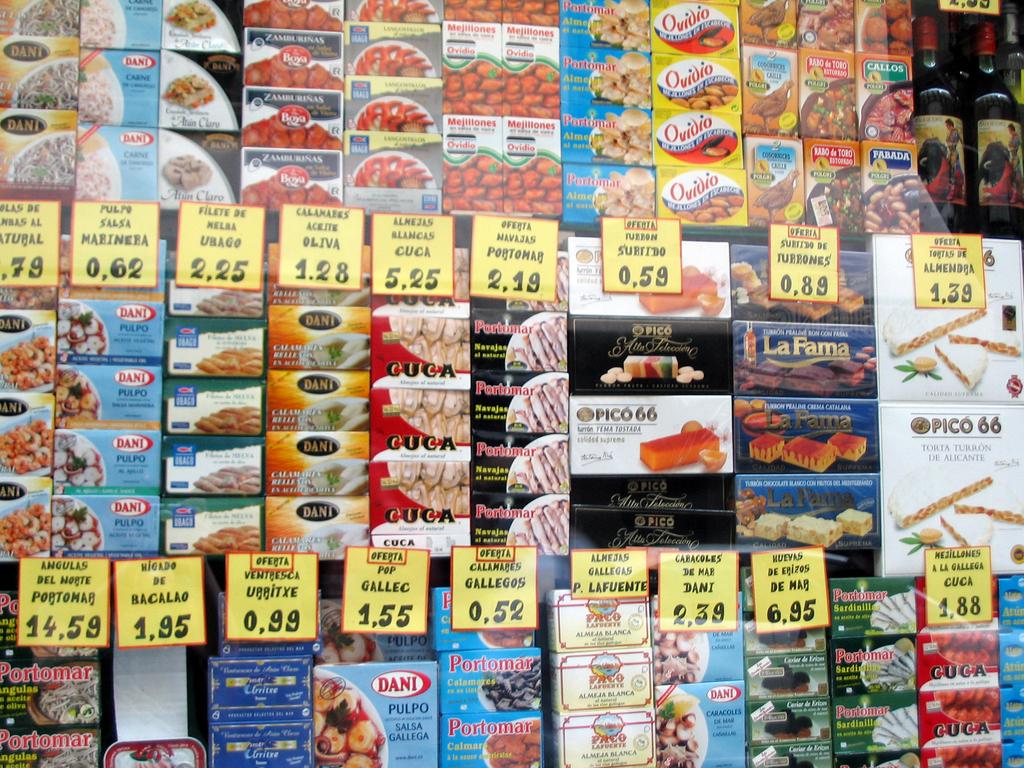How much does gallec cost?
Keep it short and to the point. 1.55. 